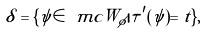<formula> <loc_0><loc_0><loc_500><loc_500>\delta = \{ \psi \in \ m c { W } _ { \phi } | \tau ^ { \prime } ( \psi ) = t \} ,</formula> 